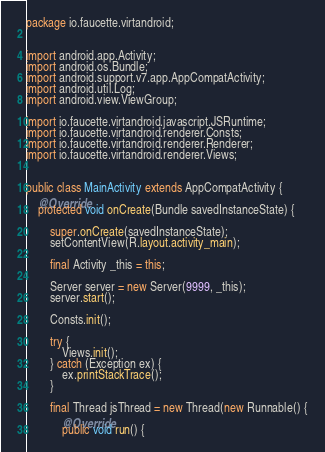<code> <loc_0><loc_0><loc_500><loc_500><_Java_>package io.faucette.virtandroid;


import android.app.Activity;
import android.os.Bundle;
import android.support.v7.app.AppCompatActivity;
import android.util.Log;
import android.view.ViewGroup;

import io.faucette.virtandroid.javascript.JSRuntime;
import io.faucette.virtandroid.renderer.Consts;
import io.faucette.virtandroid.renderer.Renderer;
import io.faucette.virtandroid.renderer.Views;


public class MainActivity extends AppCompatActivity {
    @Override
    protected void onCreate(Bundle savedInstanceState) {

        super.onCreate(savedInstanceState);
        setContentView(R.layout.activity_main);

        final Activity _this = this;

        Server server = new Server(9999, _this);
        server.start();

        Consts.init();

        try {
            Views.init();
        } catch (Exception ex) {
            ex.printStackTrace();
        }

        final Thread jsThread = new Thread(new Runnable() {
            @Override
            public void run() {</code> 